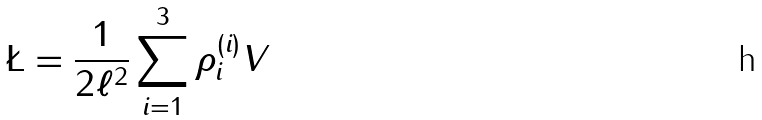Convert formula to latex. <formula><loc_0><loc_0><loc_500><loc_500>\L = \frac { 1 } { 2 \ell ^ { 2 } } \sum _ { i = 1 } ^ { 3 } \rho _ { i } ^ { ( i ) } V \</formula> 